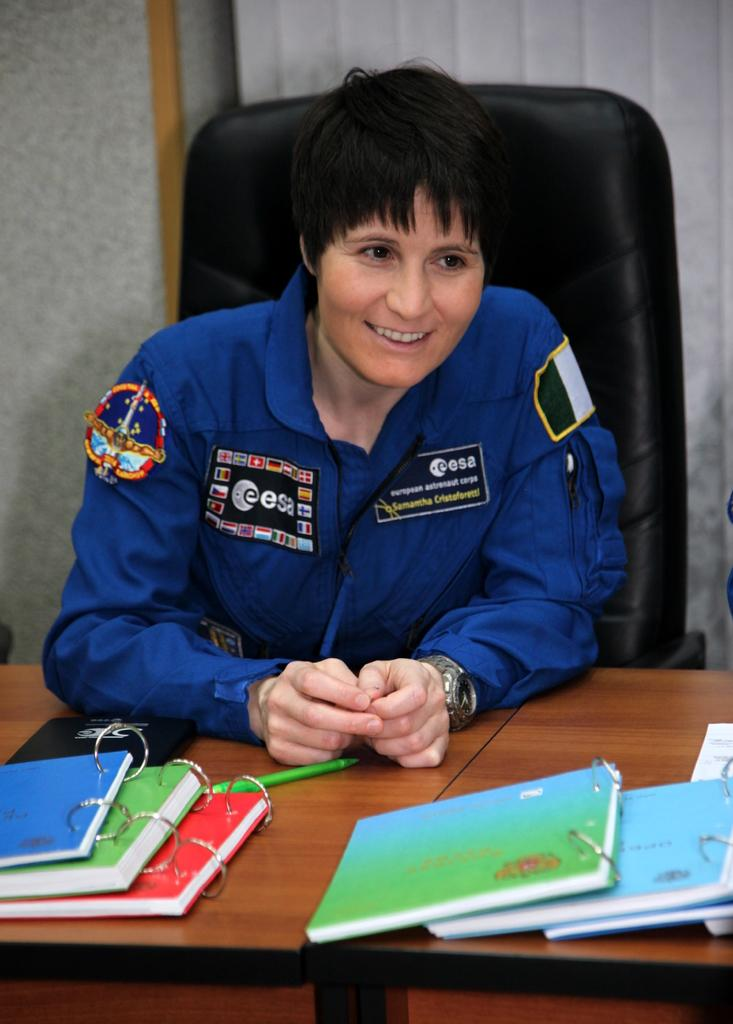What is the woman in the image doing? The woman is sitting on a chair in the image. What is the woman's facial expression in the image? The woman is smiling in the image. What objects are on the wooden table in the image? There are books and a pen on the wooden table in the image. What can be seen in the background of the image? There is a wall visible in the background of the image. Can you see the woman's friend in the image? There is no friend visible in the image; it only shows the woman sitting on a chair. 